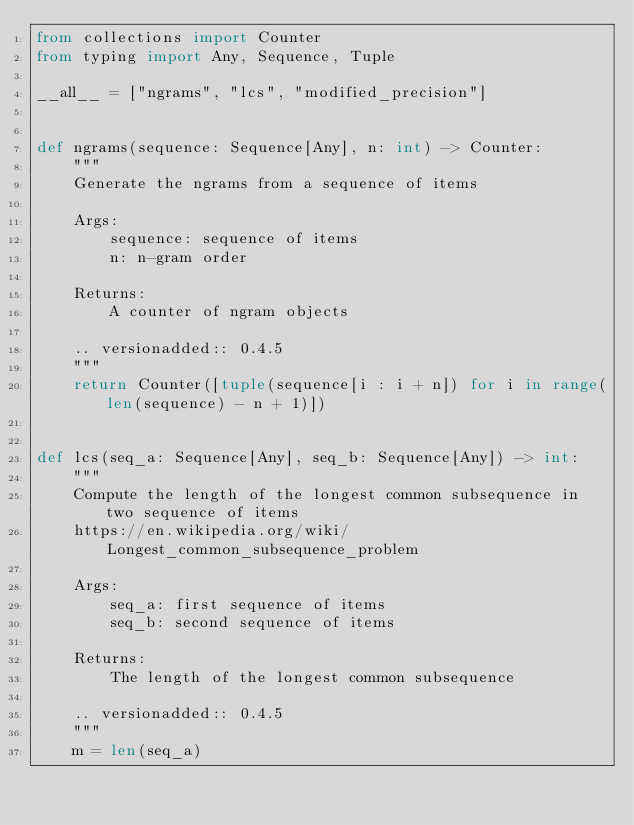Convert code to text. <code><loc_0><loc_0><loc_500><loc_500><_Python_>from collections import Counter
from typing import Any, Sequence, Tuple

__all__ = ["ngrams", "lcs", "modified_precision"]


def ngrams(sequence: Sequence[Any], n: int) -> Counter:
    """
    Generate the ngrams from a sequence of items

    Args:
        sequence: sequence of items
        n: n-gram order

    Returns:
        A counter of ngram objects

    .. versionadded:: 0.4.5
    """
    return Counter([tuple(sequence[i : i + n]) for i in range(len(sequence) - n + 1)])


def lcs(seq_a: Sequence[Any], seq_b: Sequence[Any]) -> int:
    """
    Compute the length of the longest common subsequence in two sequence of items
    https://en.wikipedia.org/wiki/Longest_common_subsequence_problem

    Args:
        seq_a: first sequence of items
        seq_b: second sequence of items

    Returns:
        The length of the longest common subsequence

    .. versionadded:: 0.4.5
    """
    m = len(seq_a)</code> 